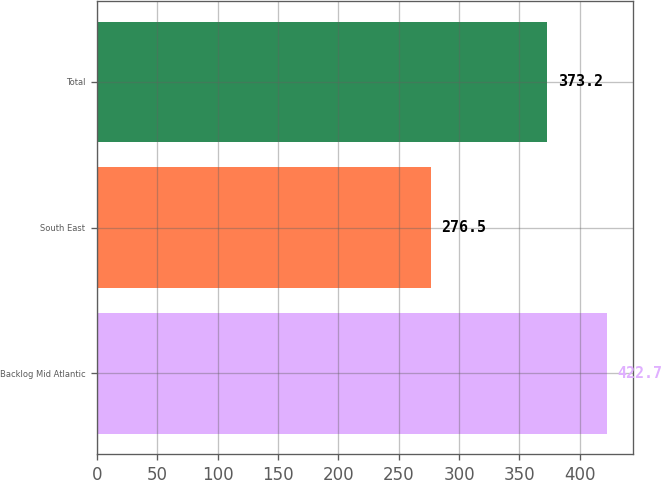Convert chart to OTSL. <chart><loc_0><loc_0><loc_500><loc_500><bar_chart><fcel>Backlog Mid Atlantic<fcel>South East<fcel>Total<nl><fcel>422.7<fcel>276.5<fcel>373.2<nl></chart> 